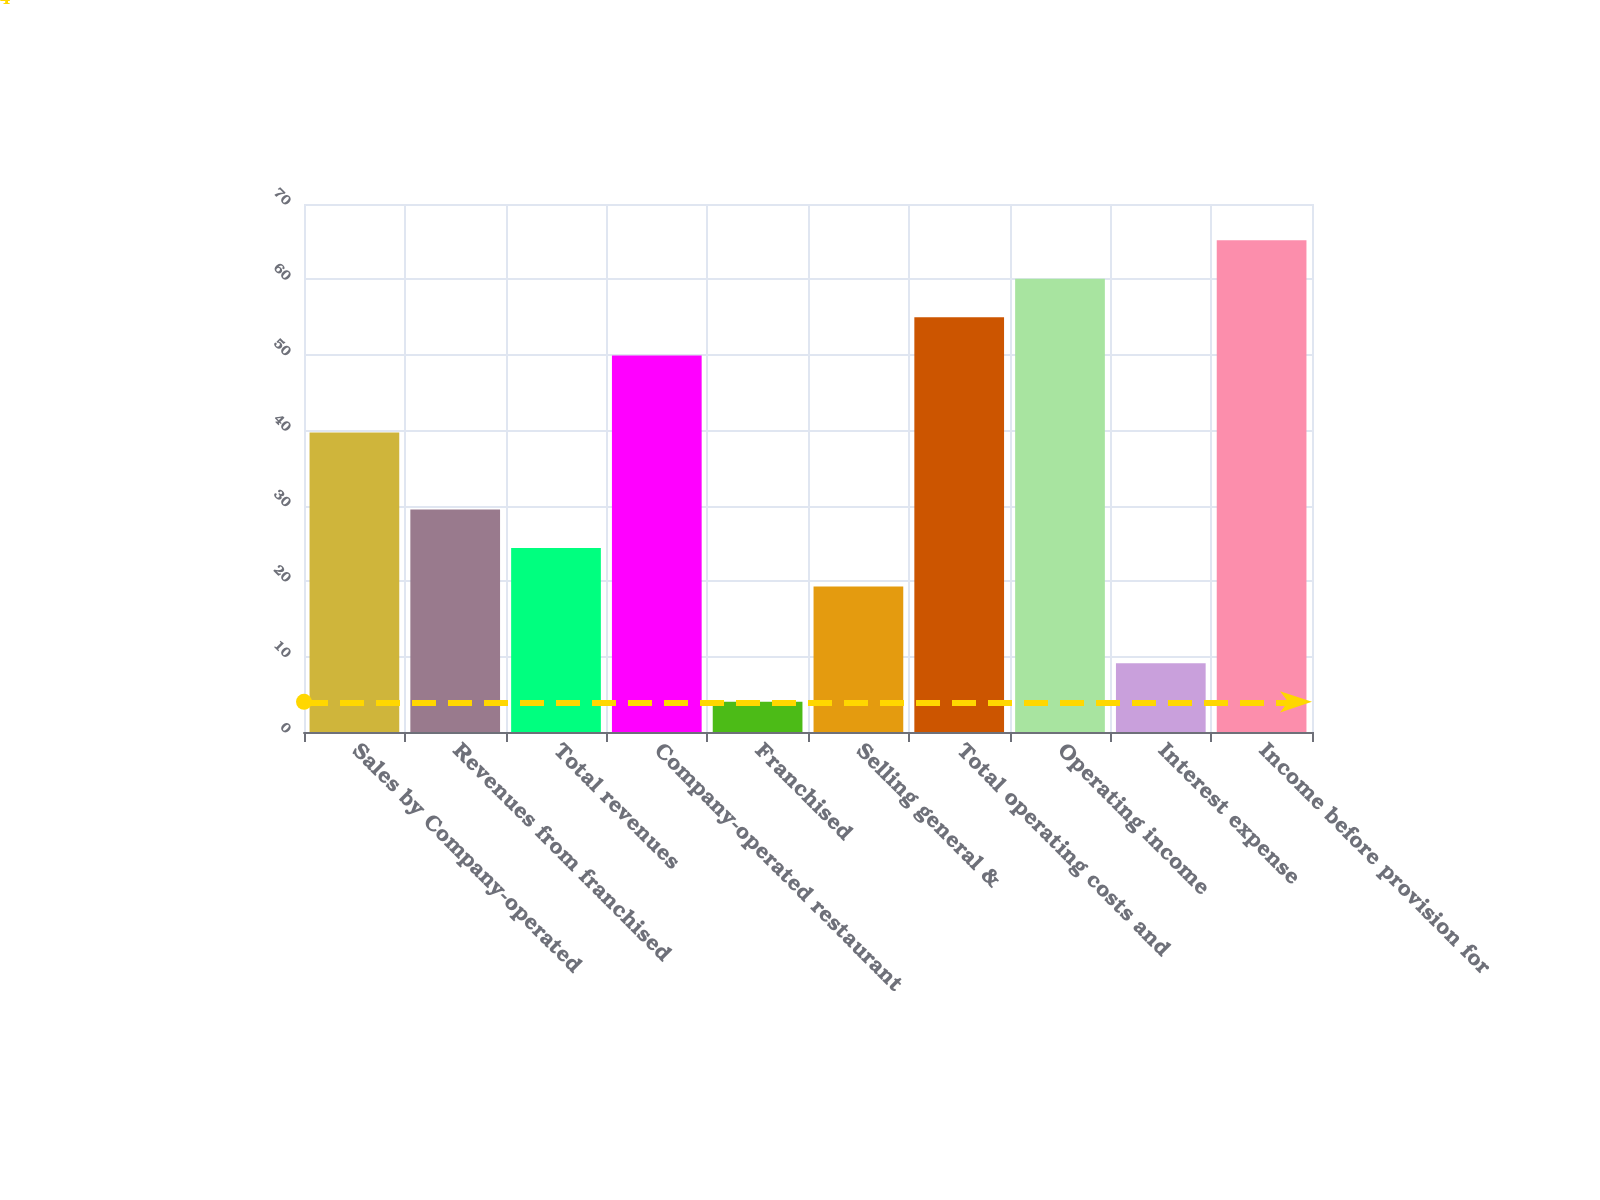<chart> <loc_0><loc_0><loc_500><loc_500><bar_chart><fcel>Sales by Company-operated<fcel>Revenues from franchised<fcel>Total revenues<fcel>Company-operated restaurant<fcel>Franchised<fcel>Selling general &<fcel>Total operating costs and<fcel>Operating income<fcel>Interest expense<fcel>Income before provision for<nl><fcel>39.7<fcel>29.5<fcel>24.4<fcel>49.9<fcel>4<fcel>19.3<fcel>55<fcel>60.1<fcel>9.1<fcel>65.2<nl></chart> 